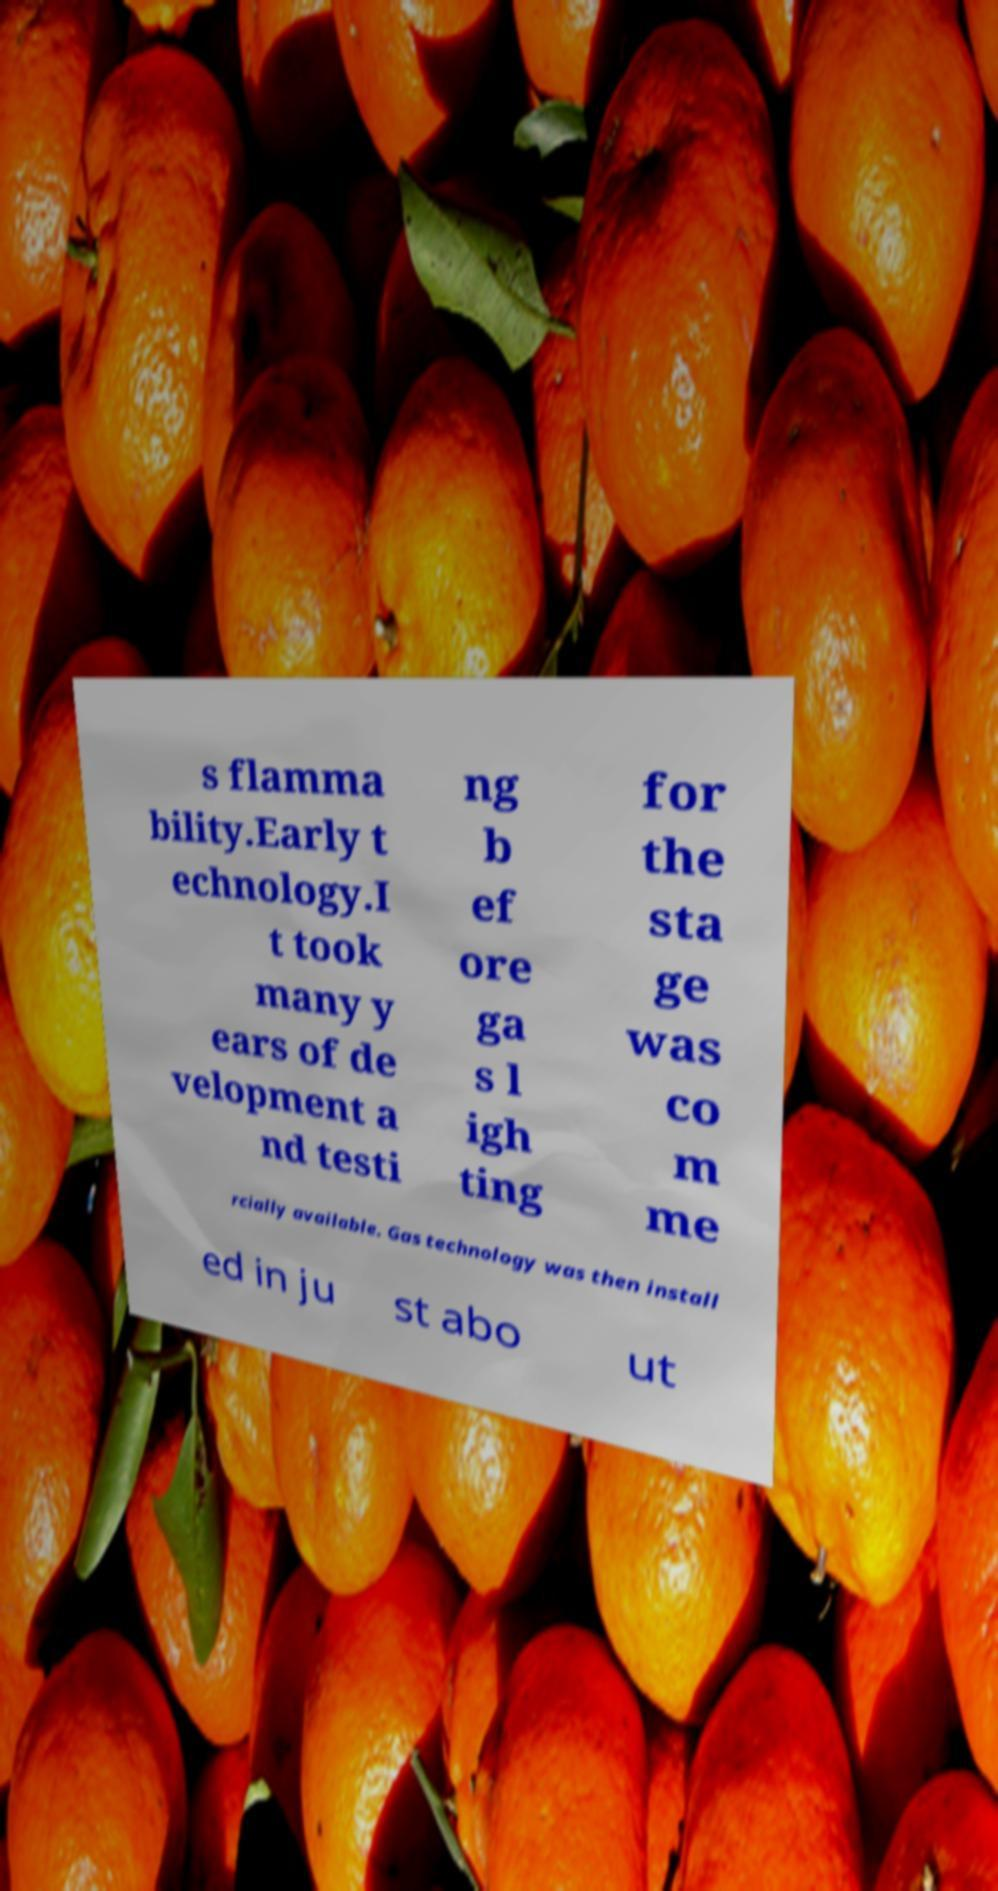Can you accurately transcribe the text from the provided image for me? s flamma bility.Early t echnology.I t took many y ears of de velopment a nd testi ng b ef ore ga s l igh ting for the sta ge was co m me rcially available. Gas technology was then install ed in ju st abo ut 